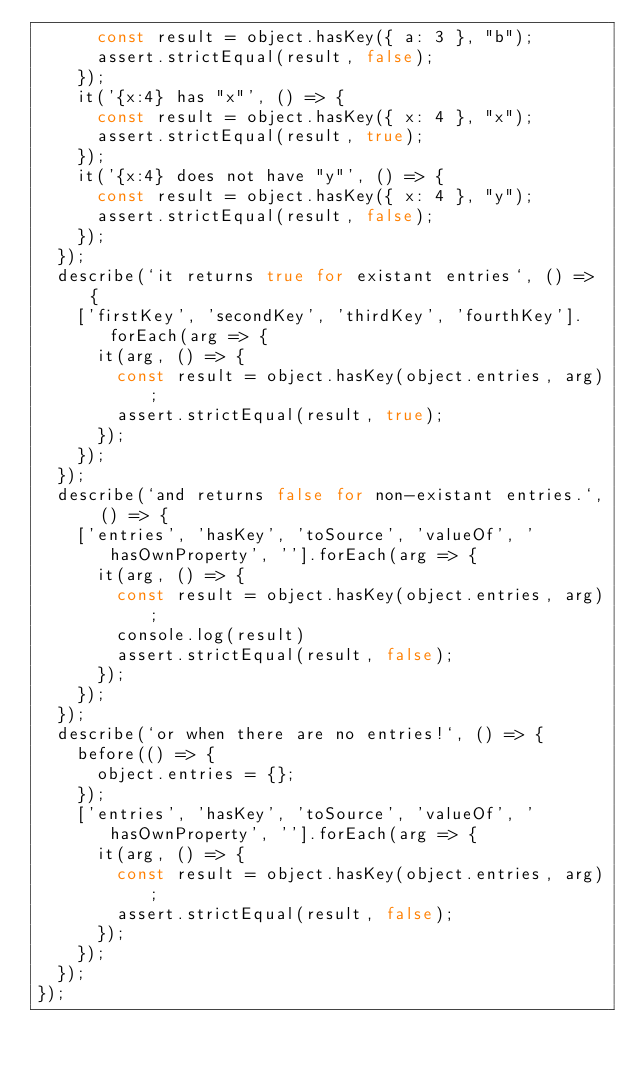Convert code to text. <code><loc_0><loc_0><loc_500><loc_500><_JavaScript_>      const result = object.hasKey({ a: 3 }, "b");
      assert.strictEqual(result, false);
    });
    it('{x:4} has "x"', () => {
      const result = object.hasKey({ x: 4 }, "x");
      assert.strictEqual(result, true);
    });
    it('{x:4} does not have "y"', () => {
      const result = object.hasKey({ x: 4 }, "y");
      assert.strictEqual(result, false);
    });
  });
  describe(`it returns true for existant entries`, () => {
    ['firstKey', 'secondKey', 'thirdKey', 'fourthKey'].forEach(arg => {
      it(arg, () => {
        const result = object.hasKey(object.entries, arg);
        assert.strictEqual(result, true);
      });
    });
  });
  describe(`and returns false for non-existant entries.`, () => {
    ['entries', 'hasKey', 'toSource', 'valueOf', 'hasOwnProperty', ''].forEach(arg => {
      it(arg, () => {
        const result = object.hasKey(object.entries, arg);
        console.log(result)
        assert.strictEqual(result, false);
      });
    });
  });
  describe(`or when there are no entries!`, () => {
    before(() => {
      object.entries = {};
    });
    ['entries', 'hasKey', 'toSource', 'valueOf', 'hasOwnProperty', ''].forEach(arg => {
      it(arg, () => {
        const result = object.hasKey(object.entries, arg);
        assert.strictEqual(result, false);
      });
    });
  });
});
</code> 